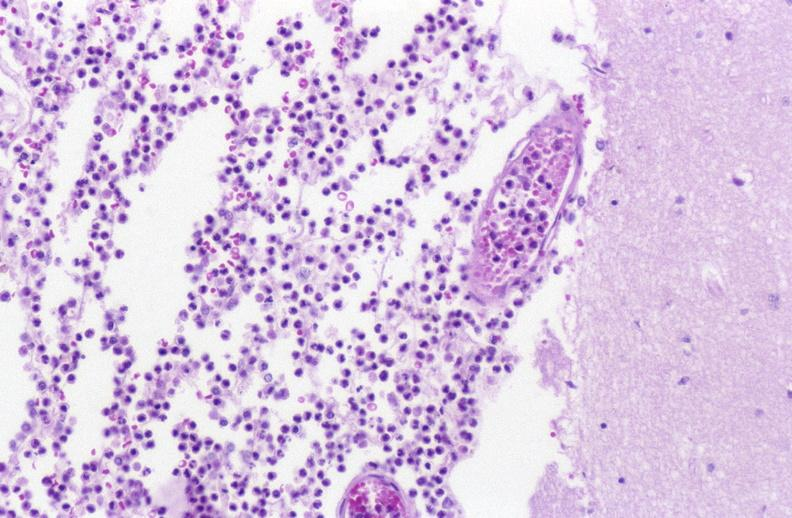what is present?
Answer the question using a single word or phrase. Nervous 